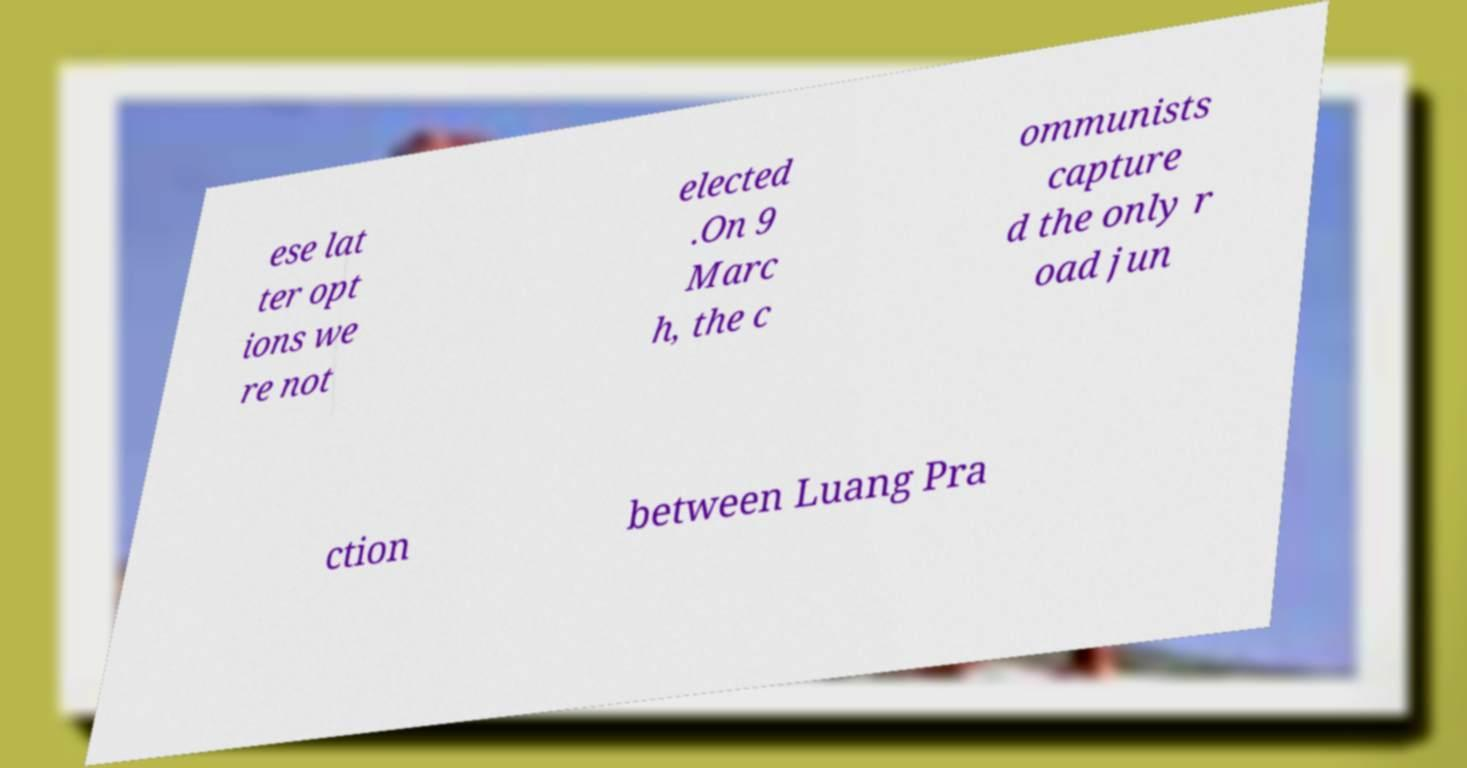Can you read and provide the text displayed in the image?This photo seems to have some interesting text. Can you extract and type it out for me? ese lat ter opt ions we re not elected .On 9 Marc h, the c ommunists capture d the only r oad jun ction between Luang Pra 